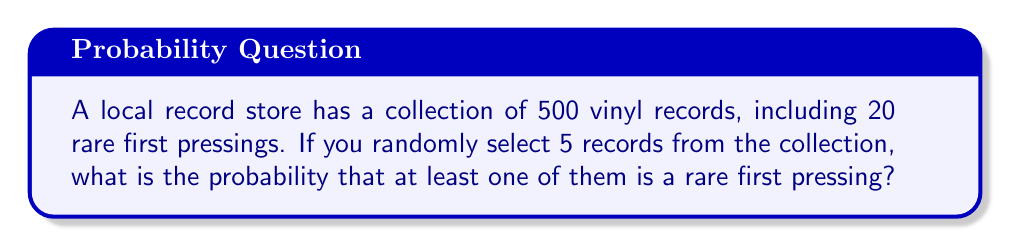Can you answer this question? Let's approach this step-by-step:

1) First, it's easier to calculate the probability of not selecting any rare records and then subtract that from 1.

2) The probability of not selecting a rare record on a single draw is:

   $\frac{480}{500} = \frac{24}{25} = 0.96$

3) For all 5 draws to not be rare, this must happen 5 times in a row. The probability of this is:

   $(\frac{24}{25})^5 = 0.96^5 \approx 0.8153$

4) Therefore, the probability of selecting at least one rare record is:

   $1 - (\frac{24}{25})^5 = 1 - 0.8153 = 0.1847$

5) We can also express this as a percentage:

   $0.1847 \times 100\% = 18.47\%$

This problem uses the complement rule of probability and assumes sampling without replacement, which is appropriate for a small number of selections relative to the total population.
Answer: $1 - (\frac{24}{25})^5 \approx 0.1847$ or $18.47\%$ 